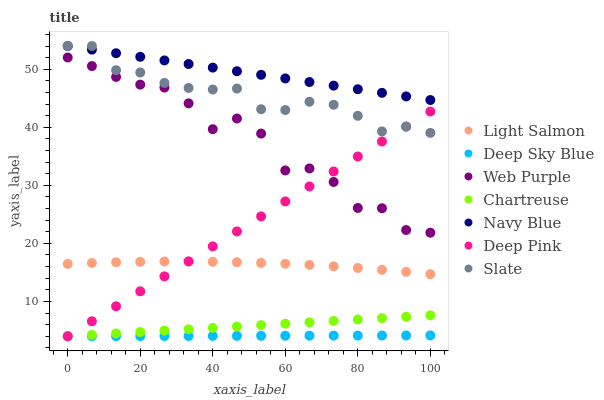Does Deep Sky Blue have the minimum area under the curve?
Answer yes or no. Yes. Does Navy Blue have the maximum area under the curve?
Answer yes or no. Yes. Does Deep Pink have the minimum area under the curve?
Answer yes or no. No. Does Deep Pink have the maximum area under the curve?
Answer yes or no. No. Is Deep Sky Blue the smoothest?
Answer yes or no. Yes. Is Web Purple the roughest?
Answer yes or no. Yes. Is Deep Pink the smoothest?
Answer yes or no. No. Is Deep Pink the roughest?
Answer yes or no. No. Does Deep Pink have the lowest value?
Answer yes or no. Yes. Does Navy Blue have the lowest value?
Answer yes or no. No. Does Slate have the highest value?
Answer yes or no. Yes. Does Deep Pink have the highest value?
Answer yes or no. No. Is Chartreuse less than Web Purple?
Answer yes or no. Yes. Is Slate greater than Light Salmon?
Answer yes or no. Yes. Does Deep Sky Blue intersect Deep Pink?
Answer yes or no. Yes. Is Deep Sky Blue less than Deep Pink?
Answer yes or no. No. Is Deep Sky Blue greater than Deep Pink?
Answer yes or no. No. Does Chartreuse intersect Web Purple?
Answer yes or no. No. 